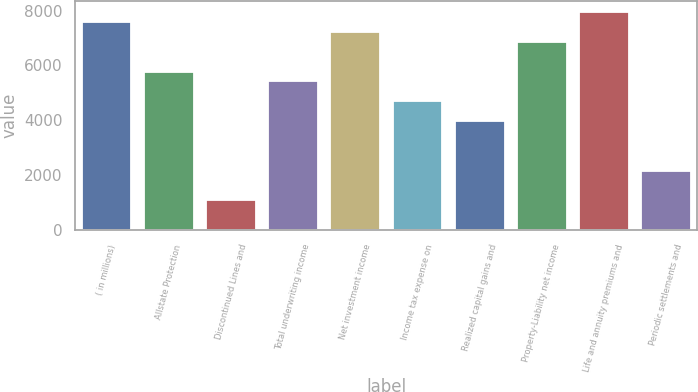Convert chart. <chart><loc_0><loc_0><loc_500><loc_500><bar_chart><fcel>( in millions)<fcel>Allstate Protection<fcel>Discontinued Lines and<fcel>Total underwriting income<fcel>Net investment income<fcel>Income tax expense on<fcel>Realized capital gains and<fcel>Property-Liability net income<fcel>Life and annuity premiums and<fcel>Periodic settlements and<nl><fcel>7584<fcel>5779<fcel>1086<fcel>5418<fcel>7223<fcel>4696<fcel>3974<fcel>6862<fcel>7945<fcel>2169<nl></chart> 